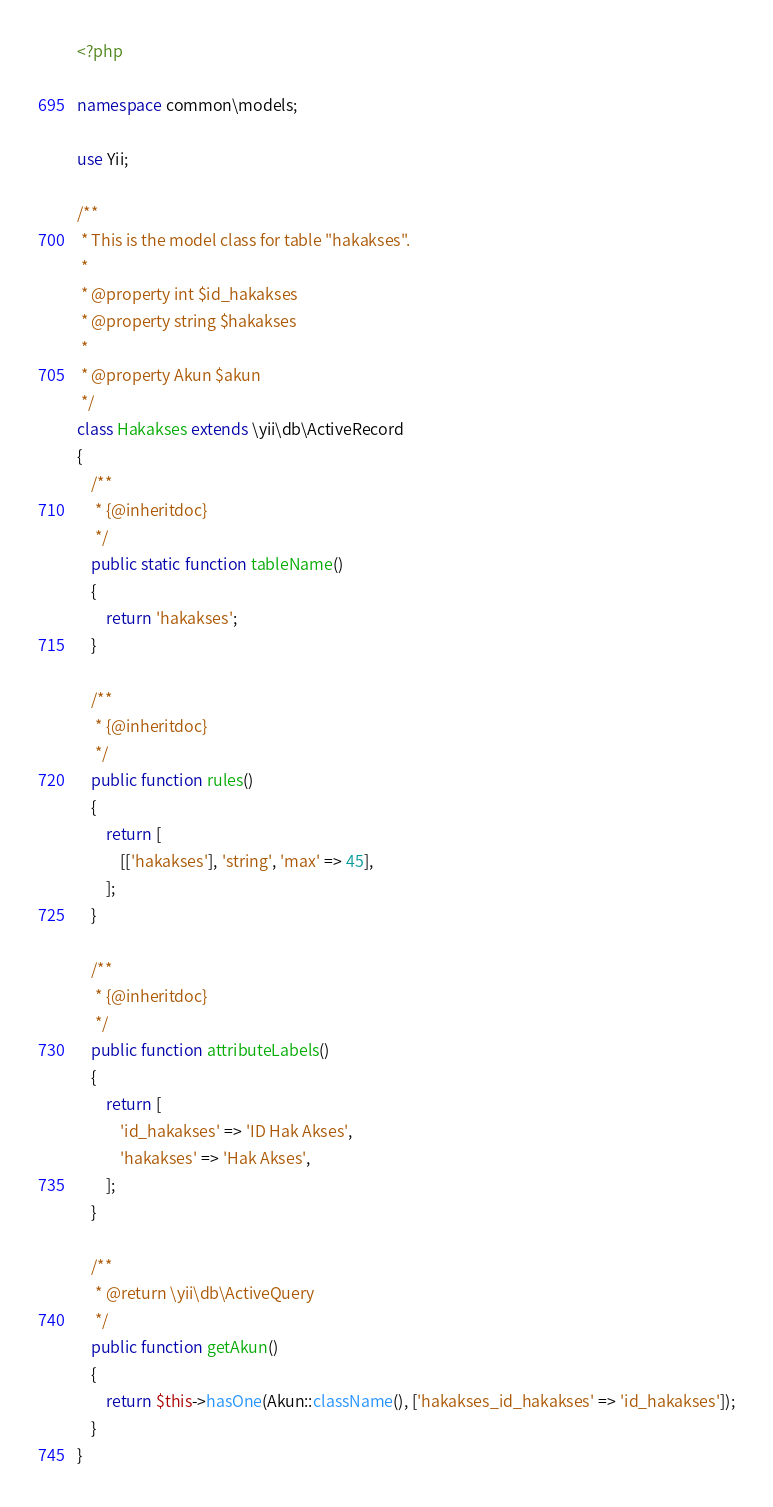Convert code to text. <code><loc_0><loc_0><loc_500><loc_500><_PHP_><?php

namespace common\models;

use Yii;

/**
 * This is the model class for table "hakakses".
 *
 * @property int $id_hakakses
 * @property string $hakakses
 *
 * @property Akun $akun
 */
class Hakakses extends \yii\db\ActiveRecord
{
    /**
     * {@inheritdoc}
     */
    public static function tableName()
    {
        return 'hakakses';
    }

    /**
     * {@inheritdoc}
     */
    public function rules()
    {
        return [
            [['hakakses'], 'string', 'max' => 45],
        ];
    }

    /**
     * {@inheritdoc}
     */
    public function attributeLabels()
    {
        return [
            'id_hakakses' => 'ID Hak Akses',
            'hakakses' => 'Hak Akses',
        ];
    }

    /**
     * @return \yii\db\ActiveQuery
     */
    public function getAkun()
    {
        return $this->hasOne(Akun::className(), ['hakakses_id_hakakses' => 'id_hakakses']);
    }
}
</code> 